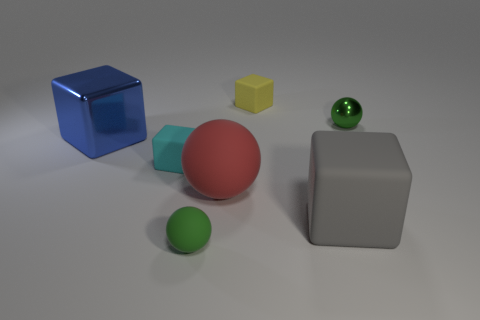There is a small object that is in front of the large blue metallic cube and on the right side of the cyan thing; what is its shape?
Keep it short and to the point. Sphere. The metallic thing to the right of the blue object has what shape?
Provide a short and direct response. Sphere. How many green things are right of the yellow matte object and to the left of the small yellow block?
Your response must be concise. 0. There is a red thing; does it have the same size as the matte cube behind the large blue thing?
Give a very brief answer. No. There is a sphere behind the tiny matte block that is in front of the green thing that is behind the big gray rubber thing; what size is it?
Give a very brief answer. Small. There is a ball that is to the left of the red thing; what size is it?
Your answer should be very brief. Small. What shape is the green object that is made of the same material as the gray thing?
Your answer should be compact. Sphere. Does the ball to the left of the large ball have the same material as the yellow block?
Provide a succinct answer. Yes. How many other objects are there of the same material as the large red ball?
Ensure brevity in your answer.  4. How many things are matte blocks behind the cyan object or spheres on the left side of the large gray block?
Provide a short and direct response. 3. 